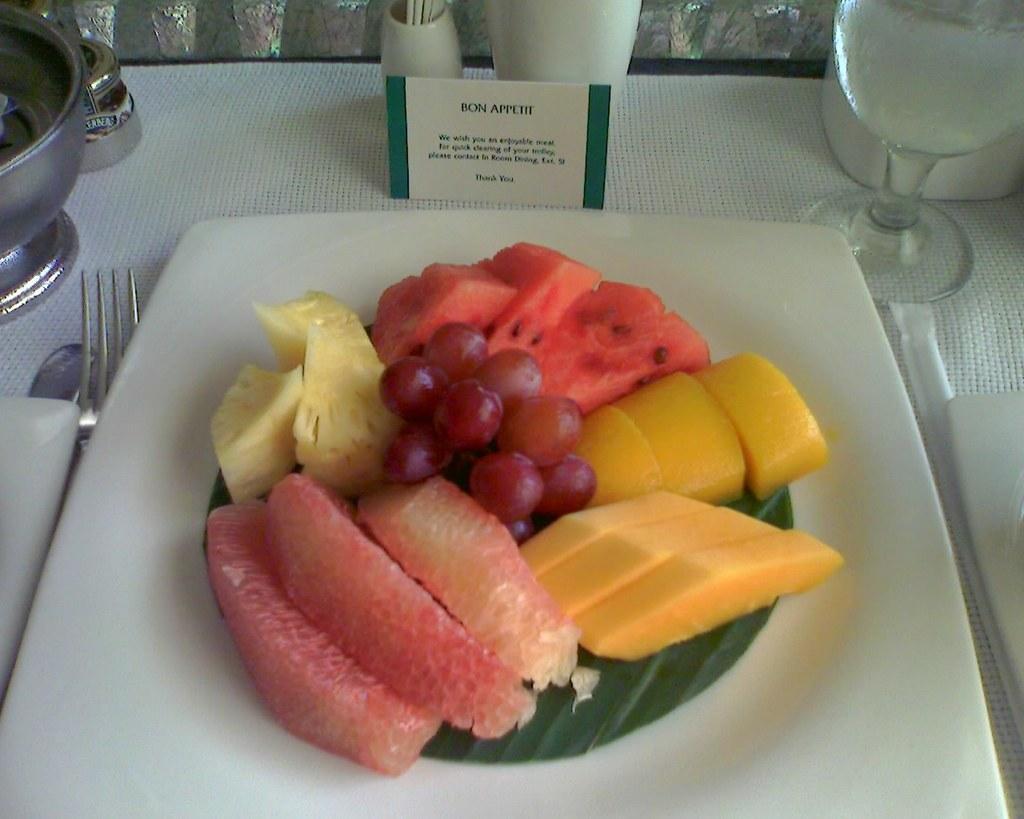Could you give a brief overview of what you see in this image? In this image there are fruits on the plate. Beside the plate there is a glass. There is a fork. There is a card and there are a few other objects on the table. 